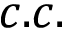Convert formula to latex. <formula><loc_0><loc_0><loc_500><loc_500>c . c .</formula> 